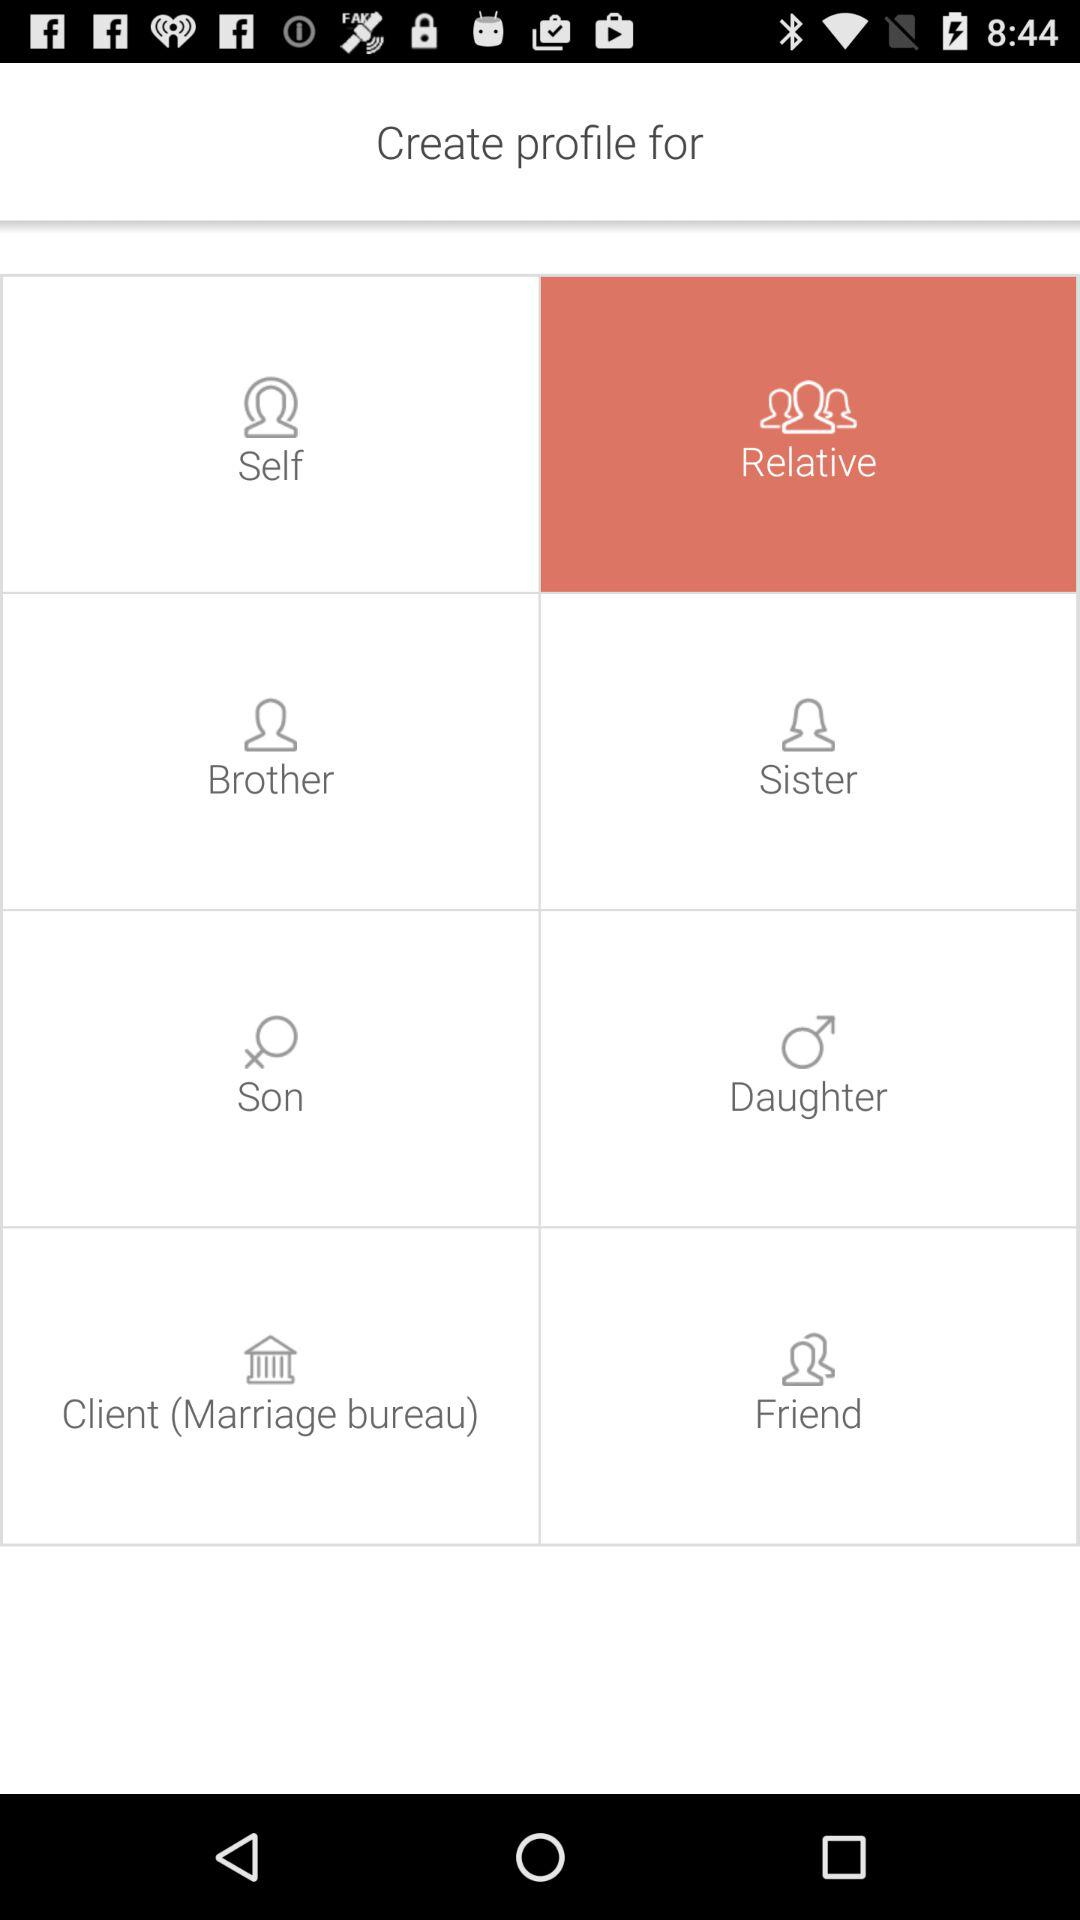How many profile types are for family members?
Answer the question using a single word or phrase. 4 